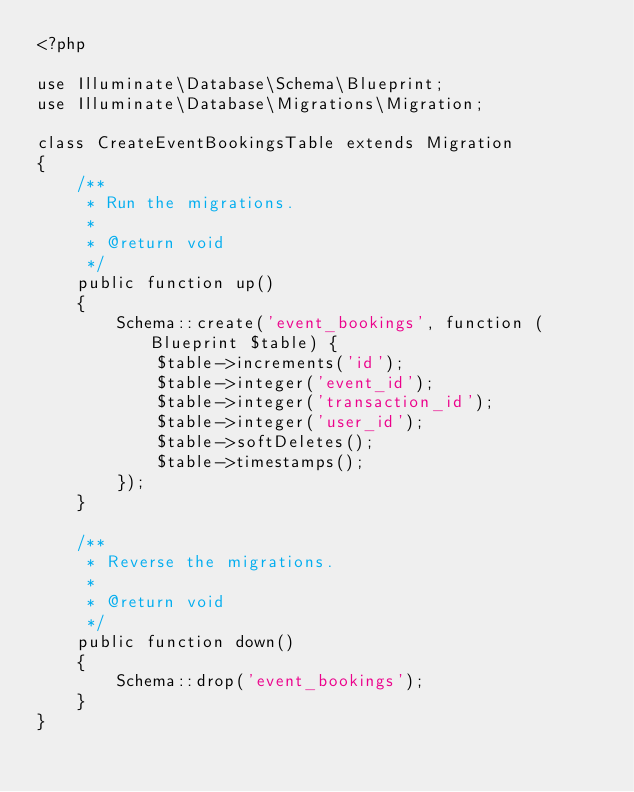Convert code to text. <code><loc_0><loc_0><loc_500><loc_500><_PHP_><?php

use Illuminate\Database\Schema\Blueprint;
use Illuminate\Database\Migrations\Migration;

class CreateEventBookingsTable extends Migration
{
    /**
     * Run the migrations.
     *
     * @return void
     */
    public function up()
    {
        Schema::create('event_bookings', function (Blueprint $table) {
            $table->increments('id');
            $table->integer('event_id');
            $table->integer('transaction_id');
            $table->integer('user_id');            
            $table->softDeletes();
            $table->timestamps();
        });
    }

    /**
     * Reverse the migrations.
     *
     * @return void
     */
    public function down()
    {
        Schema::drop('event_bookings');
    }
}
</code> 